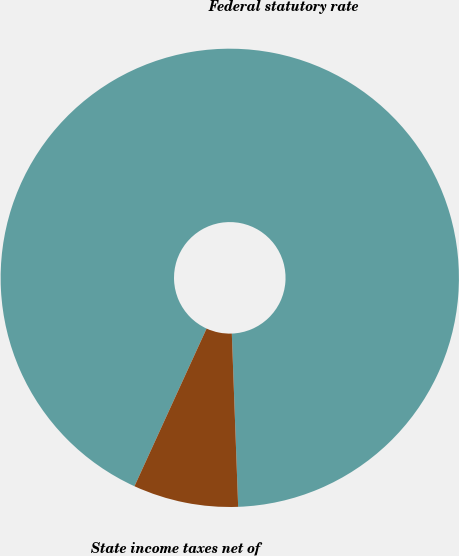Convert chart. <chart><loc_0><loc_0><loc_500><loc_500><pie_chart><fcel>Federal statutory rate<fcel>State income taxes net of<nl><fcel>92.59%<fcel>7.41%<nl></chart> 